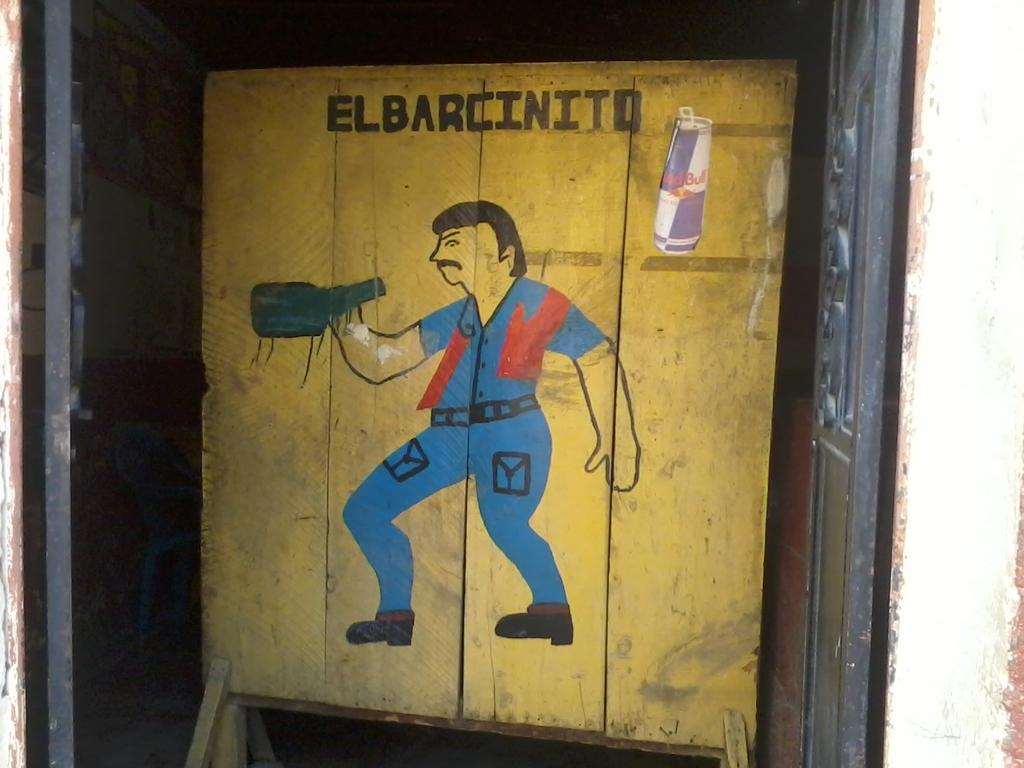<image>
Describe the image concisely. A Red Bull can is to the right of the text El Barcinito. 